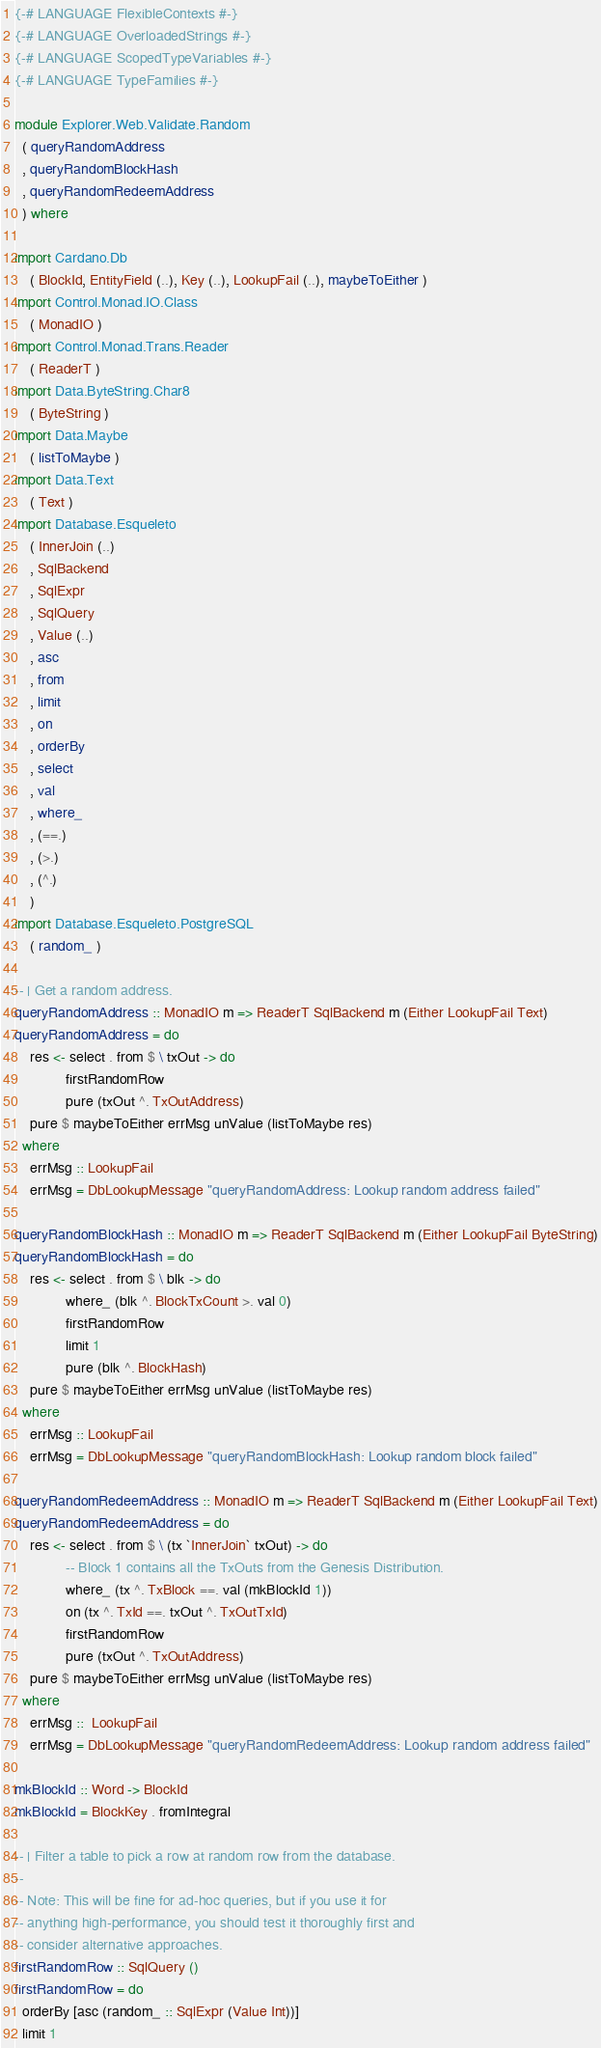Convert code to text. <code><loc_0><loc_0><loc_500><loc_500><_Haskell_>{-# LANGUAGE FlexibleContexts #-}
{-# LANGUAGE OverloadedStrings #-}
{-# LANGUAGE ScopedTypeVariables #-}
{-# LANGUAGE TypeFamilies #-}

module Explorer.Web.Validate.Random
  ( queryRandomAddress
  , queryRandomBlockHash
  , queryRandomRedeemAddress
  ) where

import Cardano.Db
    ( BlockId, EntityField (..), Key (..), LookupFail (..), maybeToEither )
import Control.Monad.IO.Class
    ( MonadIO )
import Control.Monad.Trans.Reader
    ( ReaderT )
import Data.ByteString.Char8
    ( ByteString )
import Data.Maybe
    ( listToMaybe )
import Data.Text
    ( Text )
import Database.Esqueleto
    ( InnerJoin (..)
    , SqlBackend
    , SqlExpr
    , SqlQuery
    , Value (..)
    , asc
    , from
    , limit
    , on
    , orderBy
    , select
    , val
    , where_
    , (==.)
    , (>.)
    , (^.)
    )
import Database.Esqueleto.PostgreSQL
    ( random_ )

-- | Get a random address.
queryRandomAddress :: MonadIO m => ReaderT SqlBackend m (Either LookupFail Text)
queryRandomAddress = do
    res <- select . from $ \ txOut -> do
             firstRandomRow
             pure (txOut ^. TxOutAddress)
    pure $ maybeToEither errMsg unValue (listToMaybe res)
  where
    errMsg :: LookupFail
    errMsg = DbLookupMessage "queryRandomAddress: Lookup random address failed"

queryRandomBlockHash :: MonadIO m => ReaderT SqlBackend m (Either LookupFail ByteString)
queryRandomBlockHash = do
    res <- select . from $ \ blk -> do
             where_ (blk ^. BlockTxCount >. val 0)
             firstRandomRow
             limit 1
             pure (blk ^. BlockHash)
    pure $ maybeToEither errMsg unValue (listToMaybe res)
  where
    errMsg :: LookupFail
    errMsg = DbLookupMessage "queryRandomBlockHash: Lookup random block failed"

queryRandomRedeemAddress :: MonadIO m => ReaderT SqlBackend m (Either LookupFail Text)
queryRandomRedeemAddress = do
    res <- select . from $ \ (tx `InnerJoin` txOut) -> do
             -- Block 1 contains all the TxOuts from the Genesis Distribution.
             where_ (tx ^. TxBlock ==. val (mkBlockId 1))
             on (tx ^. TxId ==. txOut ^. TxOutTxId)
             firstRandomRow
             pure (txOut ^. TxOutAddress)
    pure $ maybeToEither errMsg unValue (listToMaybe res)
  where
    errMsg ::  LookupFail
    errMsg = DbLookupMessage "queryRandomRedeemAddress: Lookup random address failed"

mkBlockId :: Word -> BlockId
mkBlockId = BlockKey . fromIntegral

-- | Filter a table to pick a row at random row from the database.
--
-- Note: This will be fine for ad-hoc queries, but if you use it for
-- anything high-performance, you should test it thoroughly first and
-- consider alternative approaches.
firstRandomRow :: SqlQuery ()
firstRandomRow = do
  orderBy [asc (random_ :: SqlExpr (Value Int))]
  limit 1
</code> 